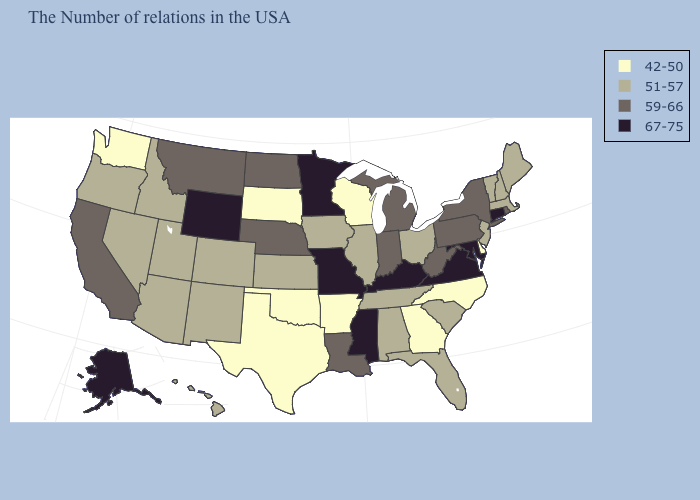Name the states that have a value in the range 59-66?
Quick response, please. Rhode Island, New York, Pennsylvania, West Virginia, Michigan, Indiana, Louisiana, Nebraska, North Dakota, Montana, California. What is the highest value in the USA?
Quick response, please. 67-75. Which states have the lowest value in the MidWest?
Answer briefly. Wisconsin, South Dakota. What is the value of Illinois?
Keep it brief. 51-57. Among the states that border Georgia , which have the highest value?
Keep it brief. South Carolina, Florida, Alabama, Tennessee. What is the value of Colorado?
Write a very short answer. 51-57. Name the states that have a value in the range 42-50?
Concise answer only. Delaware, North Carolina, Georgia, Wisconsin, Arkansas, Oklahoma, Texas, South Dakota, Washington. Name the states that have a value in the range 67-75?
Give a very brief answer. Connecticut, Maryland, Virginia, Kentucky, Mississippi, Missouri, Minnesota, Wyoming, Alaska. What is the lowest value in the USA?
Be succinct. 42-50. Name the states that have a value in the range 51-57?
Quick response, please. Maine, Massachusetts, New Hampshire, Vermont, New Jersey, South Carolina, Ohio, Florida, Alabama, Tennessee, Illinois, Iowa, Kansas, Colorado, New Mexico, Utah, Arizona, Idaho, Nevada, Oregon, Hawaii. What is the highest value in the USA?
Be succinct. 67-75. Does the map have missing data?
Quick response, please. No. What is the highest value in the MidWest ?
Concise answer only. 67-75. What is the lowest value in states that border New Mexico?
Keep it brief. 42-50. Does the map have missing data?
Answer briefly. No. 